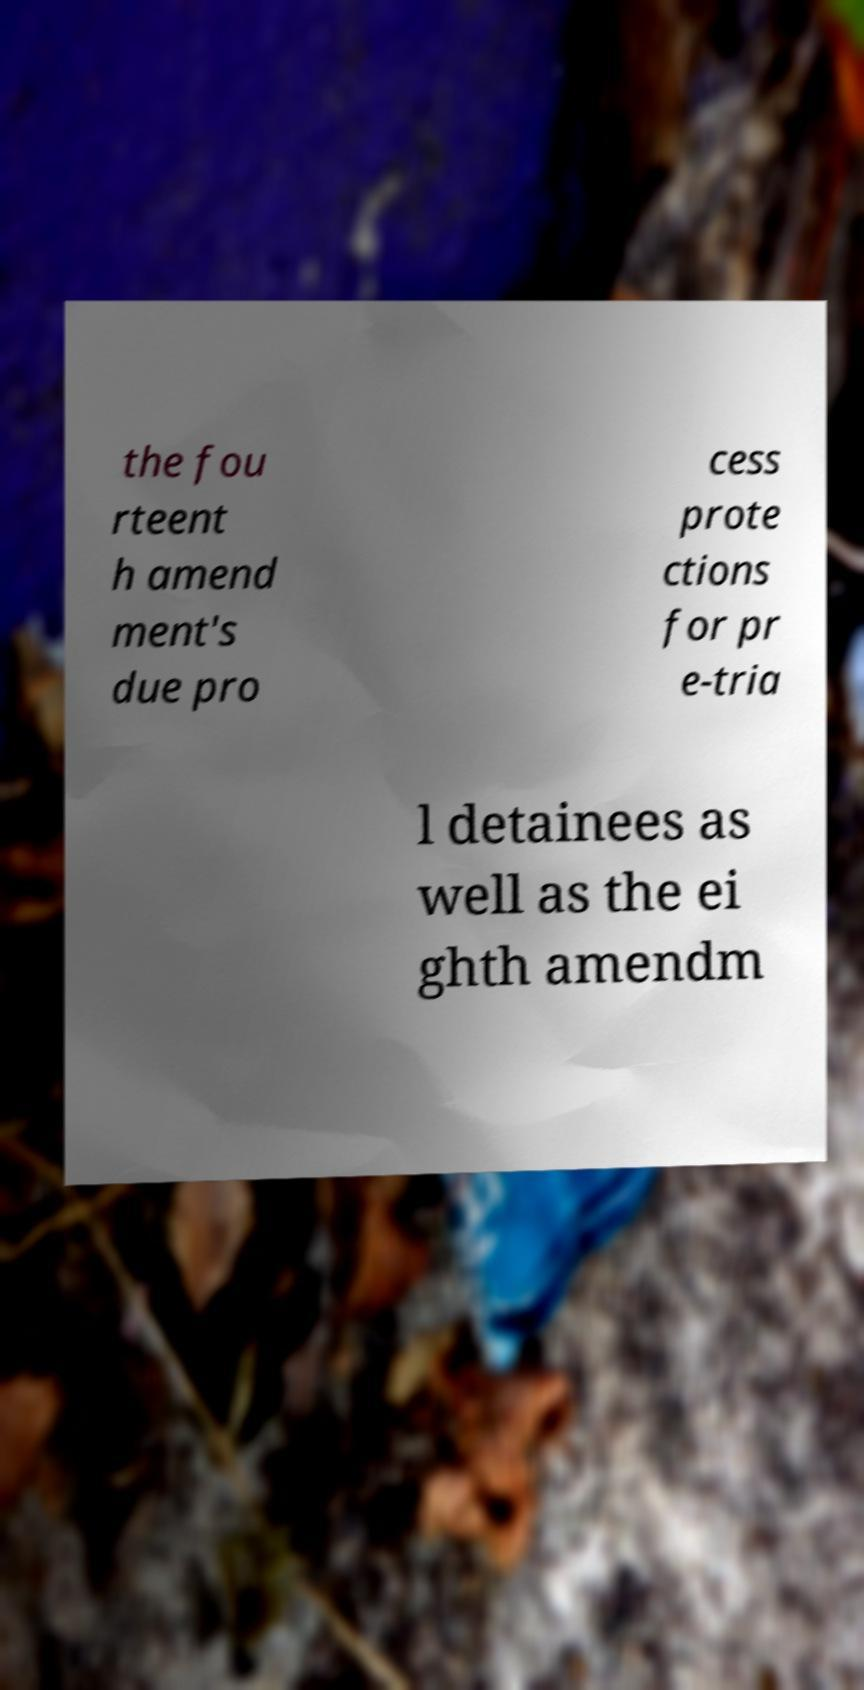There's text embedded in this image that I need extracted. Can you transcribe it verbatim? the fou rteent h amend ment's due pro cess prote ctions for pr e-tria l detainees as well as the ei ghth amendm 